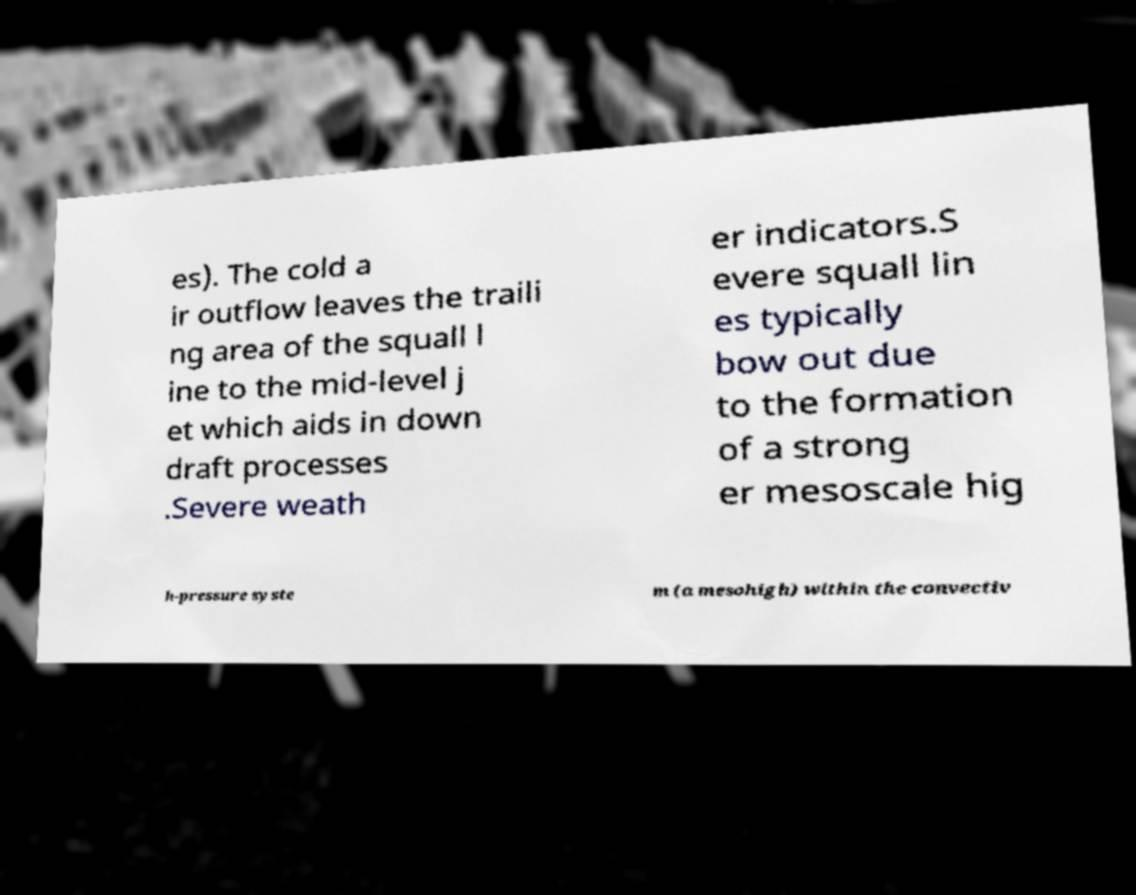There's text embedded in this image that I need extracted. Can you transcribe it verbatim? es). The cold a ir outflow leaves the traili ng area of the squall l ine to the mid-level j et which aids in down draft processes .Severe weath er indicators.S evere squall lin es typically bow out due to the formation of a strong er mesoscale hig h-pressure syste m (a mesohigh) within the convectiv 